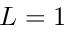Convert formula to latex. <formula><loc_0><loc_0><loc_500><loc_500>L = 1</formula> 